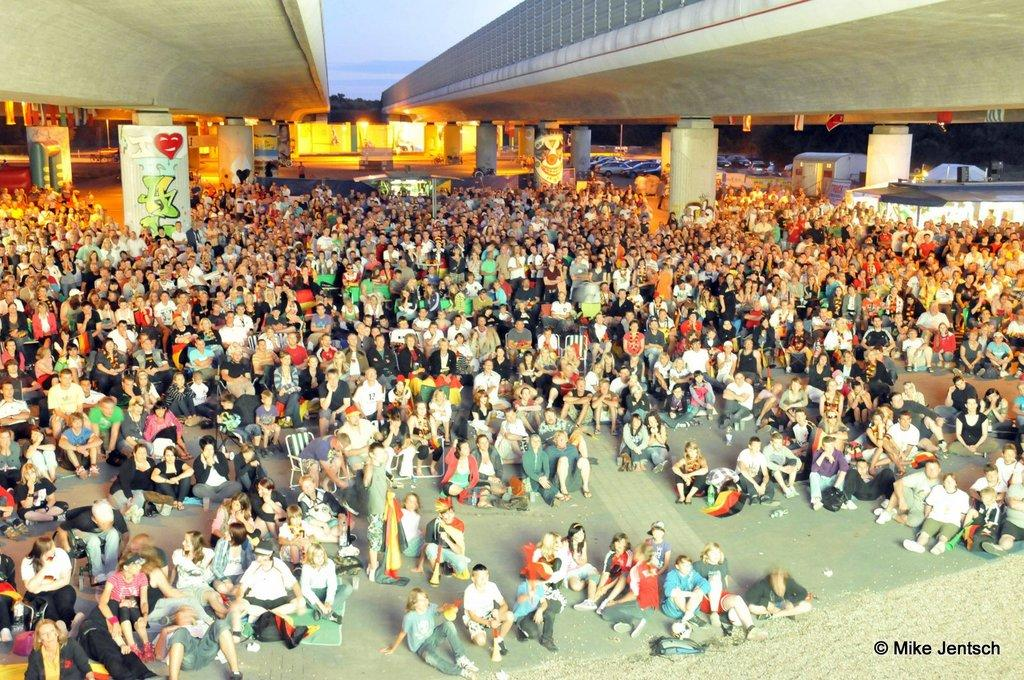What is the main subject of the image? The main subject of the image is a huge crowd. Can you describe the people in the image? There are architects on both the left and right sides of the image. What is supporting the architects in the image? There are pillars under the architects. How many pickles are being held by the architects in the image? There are no pickles present in the image; the architects are not holding any. What type of slope can be seen in the image? There is no slope present in the image. 